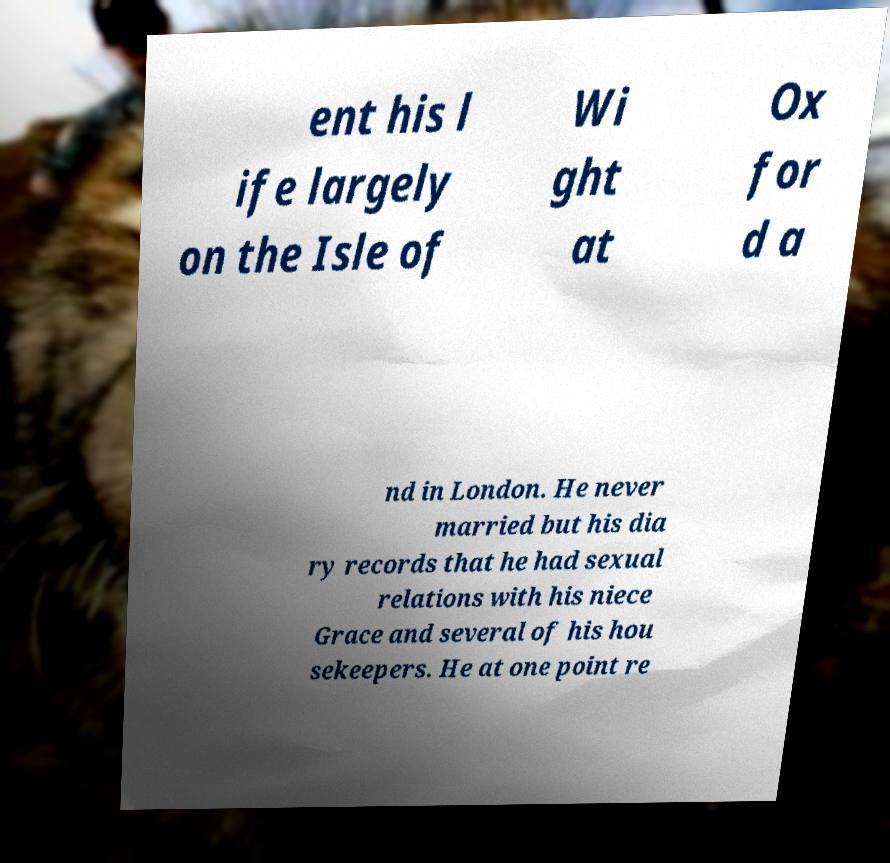There's text embedded in this image that I need extracted. Can you transcribe it verbatim? ent his l ife largely on the Isle of Wi ght at Ox for d a nd in London. He never married but his dia ry records that he had sexual relations with his niece Grace and several of his hou sekeepers. He at one point re 